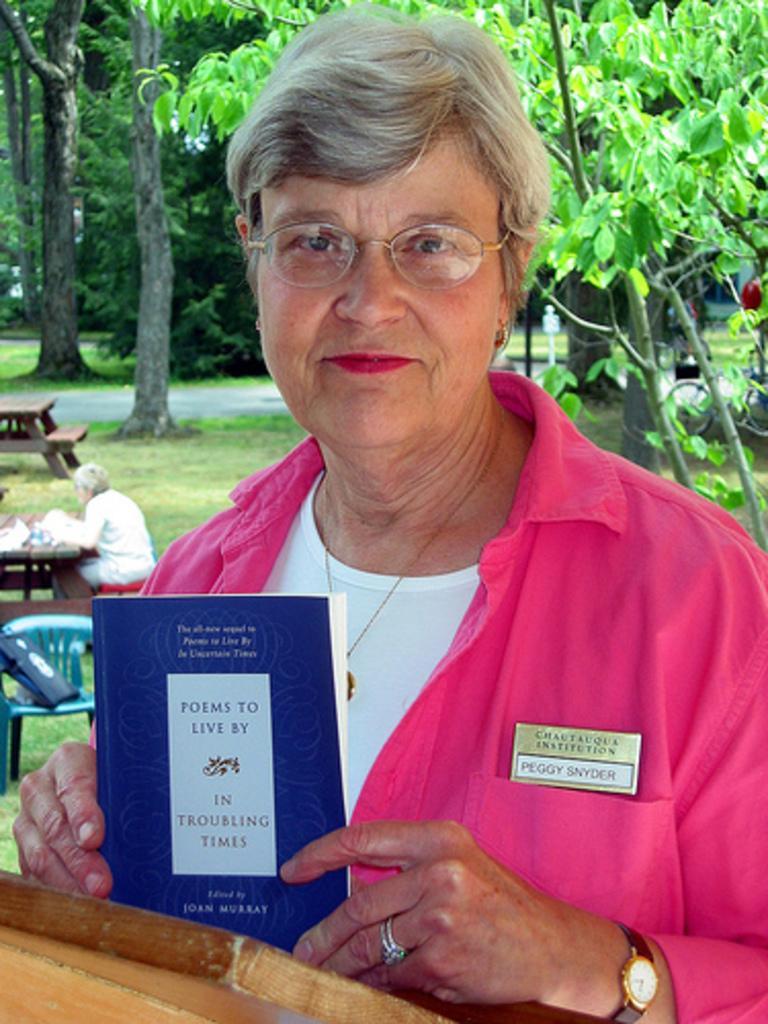How would you summarize this image in a sentence or two? In this image we can see a woman wearing pink shirt and spectacles is holding a book in her hand. In the background, we can see a person sitting on a bench and a chair containing bag is placed on the ground and group of trees. 